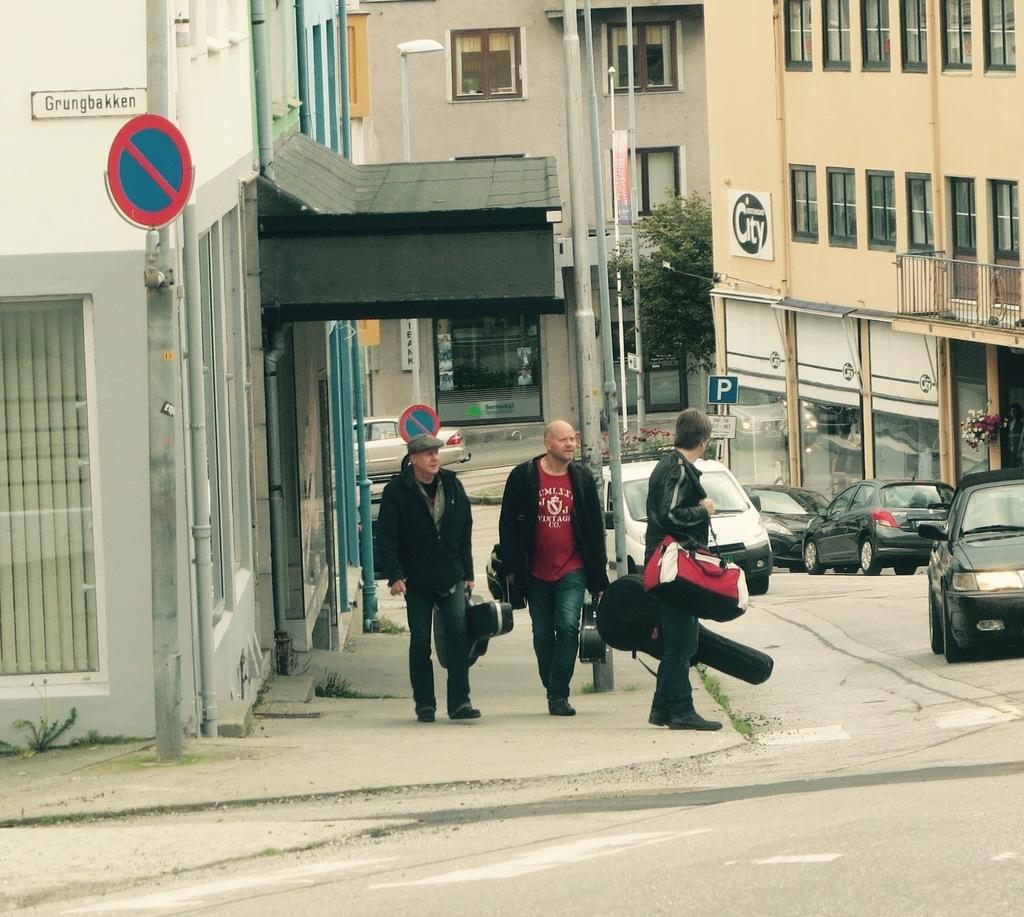<image>
Relay a brief, clear account of the picture shown. three musicians are getting ready to cross Grungbakken street 